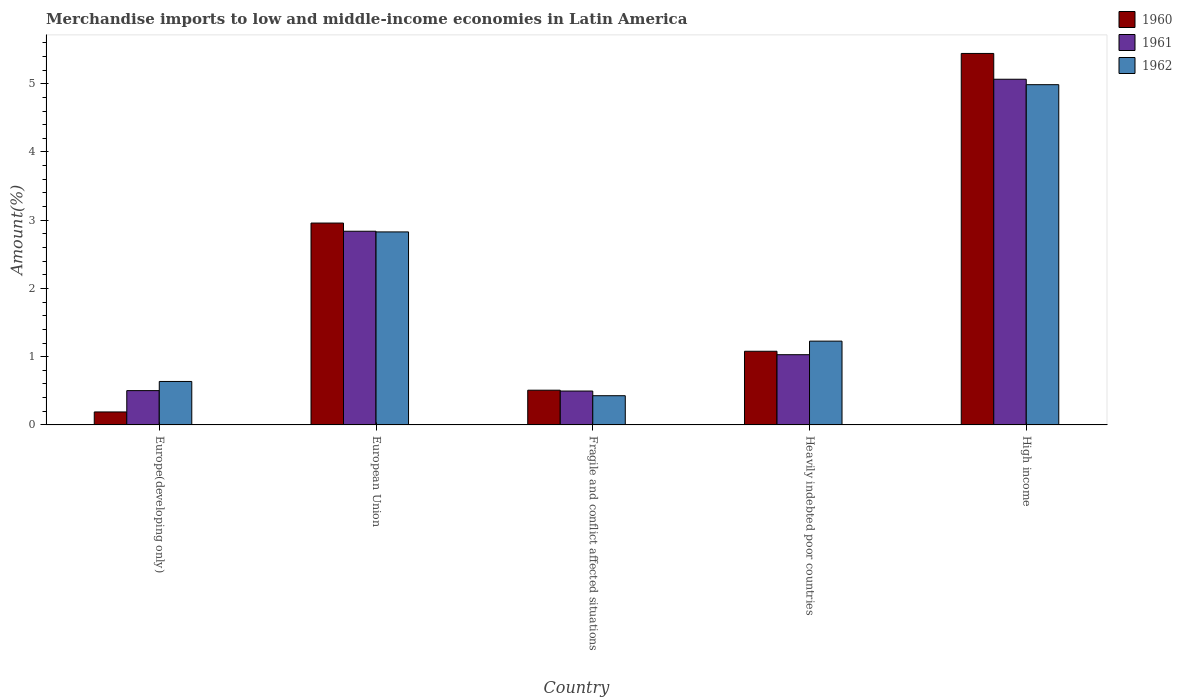How many different coloured bars are there?
Provide a short and direct response. 3. How many groups of bars are there?
Give a very brief answer. 5. Are the number of bars per tick equal to the number of legend labels?
Provide a succinct answer. Yes. Are the number of bars on each tick of the X-axis equal?
Give a very brief answer. Yes. How many bars are there on the 3rd tick from the left?
Provide a short and direct response. 3. How many bars are there on the 3rd tick from the right?
Keep it short and to the point. 3. What is the label of the 2nd group of bars from the left?
Provide a short and direct response. European Union. What is the percentage of amount earned from merchandise imports in 1962 in High income?
Provide a succinct answer. 4.99. Across all countries, what is the maximum percentage of amount earned from merchandise imports in 1962?
Your answer should be very brief. 4.99. Across all countries, what is the minimum percentage of amount earned from merchandise imports in 1962?
Provide a short and direct response. 0.43. In which country was the percentage of amount earned from merchandise imports in 1961 minimum?
Make the answer very short. Fragile and conflict affected situations. What is the total percentage of amount earned from merchandise imports in 1960 in the graph?
Keep it short and to the point. 10.18. What is the difference between the percentage of amount earned from merchandise imports in 1961 in Europe(developing only) and that in High income?
Ensure brevity in your answer.  -4.56. What is the difference between the percentage of amount earned from merchandise imports in 1962 in High income and the percentage of amount earned from merchandise imports in 1961 in European Union?
Ensure brevity in your answer.  2.15. What is the average percentage of amount earned from merchandise imports in 1960 per country?
Your answer should be compact. 2.04. What is the difference between the percentage of amount earned from merchandise imports of/in 1961 and percentage of amount earned from merchandise imports of/in 1960 in High income?
Give a very brief answer. -0.38. In how many countries, is the percentage of amount earned from merchandise imports in 1962 greater than 4.2 %?
Keep it short and to the point. 1. What is the ratio of the percentage of amount earned from merchandise imports in 1960 in Europe(developing only) to that in Fragile and conflict affected situations?
Offer a very short reply. 0.37. What is the difference between the highest and the second highest percentage of amount earned from merchandise imports in 1962?
Offer a terse response. -1.6. What is the difference between the highest and the lowest percentage of amount earned from merchandise imports in 1961?
Your answer should be compact. 4.57. Is the sum of the percentage of amount earned from merchandise imports in 1961 in Heavily indebted poor countries and High income greater than the maximum percentage of amount earned from merchandise imports in 1960 across all countries?
Your answer should be compact. Yes. What does the 1st bar from the left in Heavily indebted poor countries represents?
Your response must be concise. 1960. What does the 1st bar from the right in Europe(developing only) represents?
Ensure brevity in your answer.  1962. How many bars are there?
Your answer should be very brief. 15. Are all the bars in the graph horizontal?
Offer a terse response. No. Are the values on the major ticks of Y-axis written in scientific E-notation?
Make the answer very short. No. Does the graph contain any zero values?
Provide a short and direct response. No. Where does the legend appear in the graph?
Make the answer very short. Top right. How are the legend labels stacked?
Offer a terse response. Vertical. What is the title of the graph?
Provide a short and direct response. Merchandise imports to low and middle-income economies in Latin America. What is the label or title of the X-axis?
Your answer should be very brief. Country. What is the label or title of the Y-axis?
Ensure brevity in your answer.  Amount(%). What is the Amount(%) in 1960 in Europe(developing only)?
Your answer should be compact. 0.19. What is the Amount(%) of 1961 in Europe(developing only)?
Give a very brief answer. 0.5. What is the Amount(%) in 1962 in Europe(developing only)?
Provide a short and direct response. 0.64. What is the Amount(%) of 1960 in European Union?
Your answer should be very brief. 2.96. What is the Amount(%) in 1961 in European Union?
Offer a very short reply. 2.84. What is the Amount(%) of 1962 in European Union?
Your response must be concise. 2.83. What is the Amount(%) of 1960 in Fragile and conflict affected situations?
Your response must be concise. 0.51. What is the Amount(%) of 1961 in Fragile and conflict affected situations?
Give a very brief answer. 0.5. What is the Amount(%) in 1962 in Fragile and conflict affected situations?
Offer a terse response. 0.43. What is the Amount(%) of 1960 in Heavily indebted poor countries?
Provide a succinct answer. 1.08. What is the Amount(%) of 1961 in Heavily indebted poor countries?
Provide a succinct answer. 1.03. What is the Amount(%) of 1962 in Heavily indebted poor countries?
Your answer should be very brief. 1.23. What is the Amount(%) of 1960 in High income?
Provide a succinct answer. 5.44. What is the Amount(%) of 1961 in High income?
Keep it short and to the point. 5.07. What is the Amount(%) in 1962 in High income?
Your answer should be very brief. 4.99. Across all countries, what is the maximum Amount(%) of 1960?
Your answer should be compact. 5.44. Across all countries, what is the maximum Amount(%) in 1961?
Make the answer very short. 5.07. Across all countries, what is the maximum Amount(%) of 1962?
Your response must be concise. 4.99. Across all countries, what is the minimum Amount(%) in 1960?
Offer a very short reply. 0.19. Across all countries, what is the minimum Amount(%) in 1961?
Offer a terse response. 0.5. Across all countries, what is the minimum Amount(%) in 1962?
Make the answer very short. 0.43. What is the total Amount(%) in 1960 in the graph?
Provide a succinct answer. 10.18. What is the total Amount(%) in 1961 in the graph?
Your answer should be very brief. 9.93. What is the total Amount(%) of 1962 in the graph?
Offer a very short reply. 10.11. What is the difference between the Amount(%) of 1960 in Europe(developing only) and that in European Union?
Provide a succinct answer. -2.77. What is the difference between the Amount(%) in 1961 in Europe(developing only) and that in European Union?
Your answer should be compact. -2.34. What is the difference between the Amount(%) in 1962 in Europe(developing only) and that in European Union?
Provide a short and direct response. -2.19. What is the difference between the Amount(%) of 1960 in Europe(developing only) and that in Fragile and conflict affected situations?
Your response must be concise. -0.32. What is the difference between the Amount(%) of 1961 in Europe(developing only) and that in Fragile and conflict affected situations?
Your answer should be very brief. 0.01. What is the difference between the Amount(%) in 1962 in Europe(developing only) and that in Fragile and conflict affected situations?
Provide a short and direct response. 0.21. What is the difference between the Amount(%) of 1960 in Europe(developing only) and that in Heavily indebted poor countries?
Provide a succinct answer. -0.89. What is the difference between the Amount(%) of 1961 in Europe(developing only) and that in Heavily indebted poor countries?
Your response must be concise. -0.53. What is the difference between the Amount(%) of 1962 in Europe(developing only) and that in Heavily indebted poor countries?
Keep it short and to the point. -0.59. What is the difference between the Amount(%) of 1960 in Europe(developing only) and that in High income?
Offer a very short reply. -5.25. What is the difference between the Amount(%) of 1961 in Europe(developing only) and that in High income?
Provide a succinct answer. -4.56. What is the difference between the Amount(%) of 1962 in Europe(developing only) and that in High income?
Your answer should be very brief. -4.35. What is the difference between the Amount(%) of 1960 in European Union and that in Fragile and conflict affected situations?
Offer a very short reply. 2.45. What is the difference between the Amount(%) of 1961 in European Union and that in Fragile and conflict affected situations?
Offer a very short reply. 2.34. What is the difference between the Amount(%) in 1962 in European Union and that in Fragile and conflict affected situations?
Ensure brevity in your answer.  2.4. What is the difference between the Amount(%) in 1960 in European Union and that in Heavily indebted poor countries?
Ensure brevity in your answer.  1.88. What is the difference between the Amount(%) in 1961 in European Union and that in Heavily indebted poor countries?
Keep it short and to the point. 1.81. What is the difference between the Amount(%) of 1962 in European Union and that in Heavily indebted poor countries?
Make the answer very short. 1.6. What is the difference between the Amount(%) of 1960 in European Union and that in High income?
Ensure brevity in your answer.  -2.49. What is the difference between the Amount(%) in 1961 in European Union and that in High income?
Your answer should be compact. -2.23. What is the difference between the Amount(%) in 1962 in European Union and that in High income?
Keep it short and to the point. -2.16. What is the difference between the Amount(%) of 1960 in Fragile and conflict affected situations and that in Heavily indebted poor countries?
Give a very brief answer. -0.57. What is the difference between the Amount(%) in 1961 in Fragile and conflict affected situations and that in Heavily indebted poor countries?
Keep it short and to the point. -0.53. What is the difference between the Amount(%) of 1962 in Fragile and conflict affected situations and that in Heavily indebted poor countries?
Offer a very short reply. -0.8. What is the difference between the Amount(%) of 1960 in Fragile and conflict affected situations and that in High income?
Make the answer very short. -4.94. What is the difference between the Amount(%) in 1961 in Fragile and conflict affected situations and that in High income?
Provide a succinct answer. -4.57. What is the difference between the Amount(%) in 1962 in Fragile and conflict affected situations and that in High income?
Keep it short and to the point. -4.56. What is the difference between the Amount(%) of 1960 in Heavily indebted poor countries and that in High income?
Offer a terse response. -4.36. What is the difference between the Amount(%) in 1961 in Heavily indebted poor countries and that in High income?
Your answer should be very brief. -4.04. What is the difference between the Amount(%) of 1962 in Heavily indebted poor countries and that in High income?
Provide a short and direct response. -3.76. What is the difference between the Amount(%) of 1960 in Europe(developing only) and the Amount(%) of 1961 in European Union?
Your answer should be very brief. -2.65. What is the difference between the Amount(%) of 1960 in Europe(developing only) and the Amount(%) of 1962 in European Union?
Offer a terse response. -2.64. What is the difference between the Amount(%) in 1961 in Europe(developing only) and the Amount(%) in 1962 in European Union?
Offer a very short reply. -2.33. What is the difference between the Amount(%) of 1960 in Europe(developing only) and the Amount(%) of 1961 in Fragile and conflict affected situations?
Your answer should be very brief. -0.31. What is the difference between the Amount(%) of 1960 in Europe(developing only) and the Amount(%) of 1962 in Fragile and conflict affected situations?
Offer a very short reply. -0.24. What is the difference between the Amount(%) of 1961 in Europe(developing only) and the Amount(%) of 1962 in Fragile and conflict affected situations?
Provide a short and direct response. 0.07. What is the difference between the Amount(%) in 1960 in Europe(developing only) and the Amount(%) in 1961 in Heavily indebted poor countries?
Make the answer very short. -0.84. What is the difference between the Amount(%) of 1960 in Europe(developing only) and the Amount(%) of 1962 in Heavily indebted poor countries?
Your answer should be compact. -1.04. What is the difference between the Amount(%) in 1961 in Europe(developing only) and the Amount(%) in 1962 in Heavily indebted poor countries?
Your answer should be compact. -0.72. What is the difference between the Amount(%) of 1960 in Europe(developing only) and the Amount(%) of 1961 in High income?
Provide a short and direct response. -4.88. What is the difference between the Amount(%) of 1960 in Europe(developing only) and the Amount(%) of 1962 in High income?
Your answer should be very brief. -4.8. What is the difference between the Amount(%) of 1961 in Europe(developing only) and the Amount(%) of 1962 in High income?
Offer a very short reply. -4.48. What is the difference between the Amount(%) in 1960 in European Union and the Amount(%) in 1961 in Fragile and conflict affected situations?
Keep it short and to the point. 2.46. What is the difference between the Amount(%) in 1960 in European Union and the Amount(%) in 1962 in Fragile and conflict affected situations?
Your response must be concise. 2.53. What is the difference between the Amount(%) of 1961 in European Union and the Amount(%) of 1962 in Fragile and conflict affected situations?
Your answer should be compact. 2.41. What is the difference between the Amount(%) in 1960 in European Union and the Amount(%) in 1961 in Heavily indebted poor countries?
Provide a short and direct response. 1.93. What is the difference between the Amount(%) of 1960 in European Union and the Amount(%) of 1962 in Heavily indebted poor countries?
Your response must be concise. 1.73. What is the difference between the Amount(%) in 1961 in European Union and the Amount(%) in 1962 in Heavily indebted poor countries?
Your answer should be very brief. 1.61. What is the difference between the Amount(%) in 1960 in European Union and the Amount(%) in 1961 in High income?
Your response must be concise. -2.11. What is the difference between the Amount(%) in 1960 in European Union and the Amount(%) in 1962 in High income?
Make the answer very short. -2.03. What is the difference between the Amount(%) of 1961 in European Union and the Amount(%) of 1962 in High income?
Offer a very short reply. -2.15. What is the difference between the Amount(%) in 1960 in Fragile and conflict affected situations and the Amount(%) in 1961 in Heavily indebted poor countries?
Provide a succinct answer. -0.52. What is the difference between the Amount(%) in 1960 in Fragile and conflict affected situations and the Amount(%) in 1962 in Heavily indebted poor countries?
Your answer should be very brief. -0.72. What is the difference between the Amount(%) of 1961 in Fragile and conflict affected situations and the Amount(%) of 1962 in Heavily indebted poor countries?
Your answer should be very brief. -0.73. What is the difference between the Amount(%) in 1960 in Fragile and conflict affected situations and the Amount(%) in 1961 in High income?
Offer a terse response. -4.56. What is the difference between the Amount(%) of 1960 in Fragile and conflict affected situations and the Amount(%) of 1962 in High income?
Your answer should be very brief. -4.48. What is the difference between the Amount(%) of 1961 in Fragile and conflict affected situations and the Amount(%) of 1962 in High income?
Give a very brief answer. -4.49. What is the difference between the Amount(%) in 1960 in Heavily indebted poor countries and the Amount(%) in 1961 in High income?
Make the answer very short. -3.99. What is the difference between the Amount(%) of 1960 in Heavily indebted poor countries and the Amount(%) of 1962 in High income?
Keep it short and to the point. -3.91. What is the difference between the Amount(%) in 1961 in Heavily indebted poor countries and the Amount(%) in 1962 in High income?
Make the answer very short. -3.96. What is the average Amount(%) of 1960 per country?
Keep it short and to the point. 2.04. What is the average Amount(%) in 1961 per country?
Offer a very short reply. 1.99. What is the average Amount(%) in 1962 per country?
Your answer should be compact. 2.02. What is the difference between the Amount(%) in 1960 and Amount(%) in 1961 in Europe(developing only)?
Offer a terse response. -0.31. What is the difference between the Amount(%) in 1960 and Amount(%) in 1962 in Europe(developing only)?
Offer a terse response. -0.45. What is the difference between the Amount(%) of 1961 and Amount(%) of 1962 in Europe(developing only)?
Provide a short and direct response. -0.13. What is the difference between the Amount(%) in 1960 and Amount(%) in 1961 in European Union?
Keep it short and to the point. 0.12. What is the difference between the Amount(%) in 1960 and Amount(%) in 1962 in European Union?
Offer a terse response. 0.13. What is the difference between the Amount(%) in 1961 and Amount(%) in 1962 in European Union?
Offer a terse response. 0.01. What is the difference between the Amount(%) of 1960 and Amount(%) of 1961 in Fragile and conflict affected situations?
Provide a succinct answer. 0.01. What is the difference between the Amount(%) in 1960 and Amount(%) in 1962 in Fragile and conflict affected situations?
Provide a succinct answer. 0.08. What is the difference between the Amount(%) in 1961 and Amount(%) in 1962 in Fragile and conflict affected situations?
Provide a short and direct response. 0.07. What is the difference between the Amount(%) of 1960 and Amount(%) of 1961 in Heavily indebted poor countries?
Offer a very short reply. 0.05. What is the difference between the Amount(%) in 1960 and Amount(%) in 1962 in Heavily indebted poor countries?
Provide a short and direct response. -0.15. What is the difference between the Amount(%) in 1961 and Amount(%) in 1962 in Heavily indebted poor countries?
Your answer should be very brief. -0.2. What is the difference between the Amount(%) in 1960 and Amount(%) in 1961 in High income?
Your answer should be very brief. 0.38. What is the difference between the Amount(%) in 1960 and Amount(%) in 1962 in High income?
Provide a succinct answer. 0.46. What is the difference between the Amount(%) in 1961 and Amount(%) in 1962 in High income?
Your response must be concise. 0.08. What is the ratio of the Amount(%) of 1960 in Europe(developing only) to that in European Union?
Keep it short and to the point. 0.06. What is the ratio of the Amount(%) of 1961 in Europe(developing only) to that in European Union?
Your answer should be very brief. 0.18. What is the ratio of the Amount(%) of 1962 in Europe(developing only) to that in European Union?
Your answer should be very brief. 0.23. What is the ratio of the Amount(%) in 1960 in Europe(developing only) to that in Fragile and conflict affected situations?
Your answer should be very brief. 0.37. What is the ratio of the Amount(%) in 1961 in Europe(developing only) to that in Fragile and conflict affected situations?
Ensure brevity in your answer.  1.01. What is the ratio of the Amount(%) in 1962 in Europe(developing only) to that in Fragile and conflict affected situations?
Ensure brevity in your answer.  1.49. What is the ratio of the Amount(%) in 1960 in Europe(developing only) to that in Heavily indebted poor countries?
Provide a short and direct response. 0.18. What is the ratio of the Amount(%) in 1961 in Europe(developing only) to that in Heavily indebted poor countries?
Ensure brevity in your answer.  0.49. What is the ratio of the Amount(%) of 1962 in Europe(developing only) to that in Heavily indebted poor countries?
Offer a terse response. 0.52. What is the ratio of the Amount(%) in 1960 in Europe(developing only) to that in High income?
Provide a succinct answer. 0.03. What is the ratio of the Amount(%) in 1961 in Europe(developing only) to that in High income?
Provide a succinct answer. 0.1. What is the ratio of the Amount(%) in 1962 in Europe(developing only) to that in High income?
Offer a very short reply. 0.13. What is the ratio of the Amount(%) of 1960 in European Union to that in Fragile and conflict affected situations?
Keep it short and to the point. 5.81. What is the ratio of the Amount(%) of 1961 in European Union to that in Fragile and conflict affected situations?
Provide a succinct answer. 5.72. What is the ratio of the Amount(%) in 1962 in European Union to that in Fragile and conflict affected situations?
Make the answer very short. 6.61. What is the ratio of the Amount(%) in 1960 in European Union to that in Heavily indebted poor countries?
Your response must be concise. 2.74. What is the ratio of the Amount(%) of 1961 in European Union to that in Heavily indebted poor countries?
Ensure brevity in your answer.  2.76. What is the ratio of the Amount(%) of 1962 in European Union to that in Heavily indebted poor countries?
Your answer should be very brief. 2.3. What is the ratio of the Amount(%) of 1960 in European Union to that in High income?
Give a very brief answer. 0.54. What is the ratio of the Amount(%) in 1961 in European Union to that in High income?
Offer a terse response. 0.56. What is the ratio of the Amount(%) in 1962 in European Union to that in High income?
Ensure brevity in your answer.  0.57. What is the ratio of the Amount(%) in 1960 in Fragile and conflict affected situations to that in Heavily indebted poor countries?
Your answer should be very brief. 0.47. What is the ratio of the Amount(%) in 1961 in Fragile and conflict affected situations to that in Heavily indebted poor countries?
Provide a succinct answer. 0.48. What is the ratio of the Amount(%) in 1962 in Fragile and conflict affected situations to that in Heavily indebted poor countries?
Your answer should be compact. 0.35. What is the ratio of the Amount(%) of 1960 in Fragile and conflict affected situations to that in High income?
Make the answer very short. 0.09. What is the ratio of the Amount(%) of 1961 in Fragile and conflict affected situations to that in High income?
Your answer should be compact. 0.1. What is the ratio of the Amount(%) in 1962 in Fragile and conflict affected situations to that in High income?
Your answer should be compact. 0.09. What is the ratio of the Amount(%) of 1960 in Heavily indebted poor countries to that in High income?
Ensure brevity in your answer.  0.2. What is the ratio of the Amount(%) in 1961 in Heavily indebted poor countries to that in High income?
Keep it short and to the point. 0.2. What is the ratio of the Amount(%) of 1962 in Heavily indebted poor countries to that in High income?
Offer a terse response. 0.25. What is the difference between the highest and the second highest Amount(%) in 1960?
Your answer should be very brief. 2.49. What is the difference between the highest and the second highest Amount(%) in 1961?
Your response must be concise. 2.23. What is the difference between the highest and the second highest Amount(%) of 1962?
Your answer should be compact. 2.16. What is the difference between the highest and the lowest Amount(%) of 1960?
Your response must be concise. 5.25. What is the difference between the highest and the lowest Amount(%) in 1961?
Your answer should be very brief. 4.57. What is the difference between the highest and the lowest Amount(%) of 1962?
Provide a short and direct response. 4.56. 